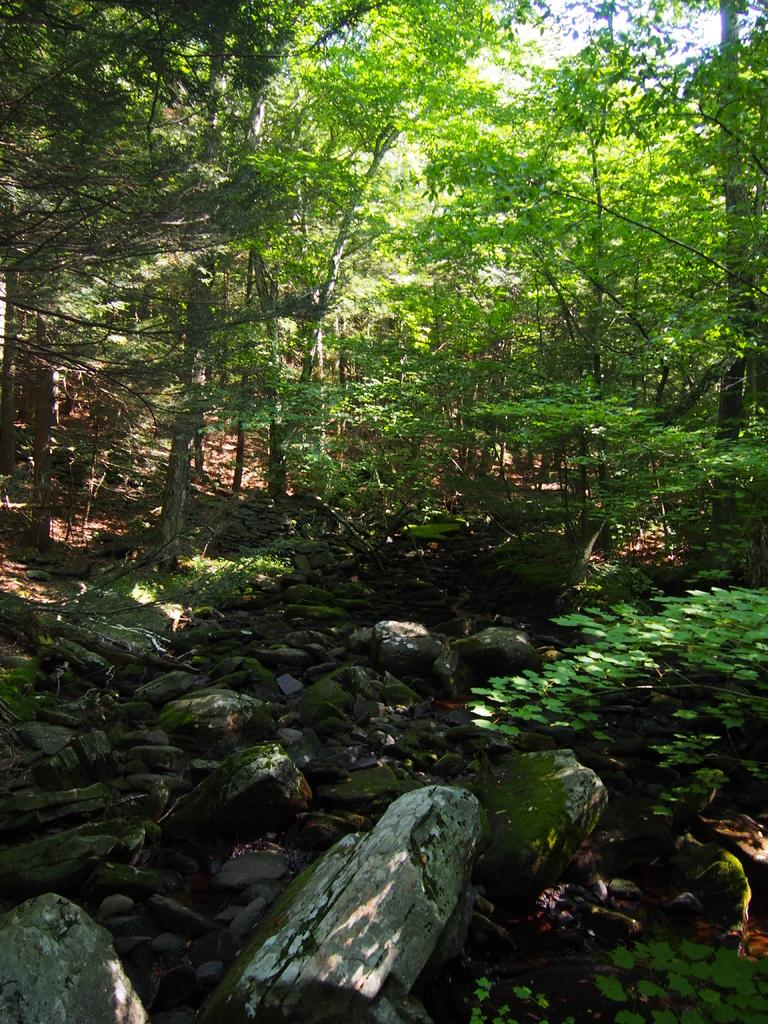What type of vegetation is present in the image? There is a group of trees and plants in the image. What else can be seen on the ground in the image? There are stones in the image. Where are the plants located in the image? The plants are in the right corner of the image. What type of straw is being used to measure the height of the trees in the image? There is no straw or measuring activity present in the image; it only features a group of trees, stones, and plants. 